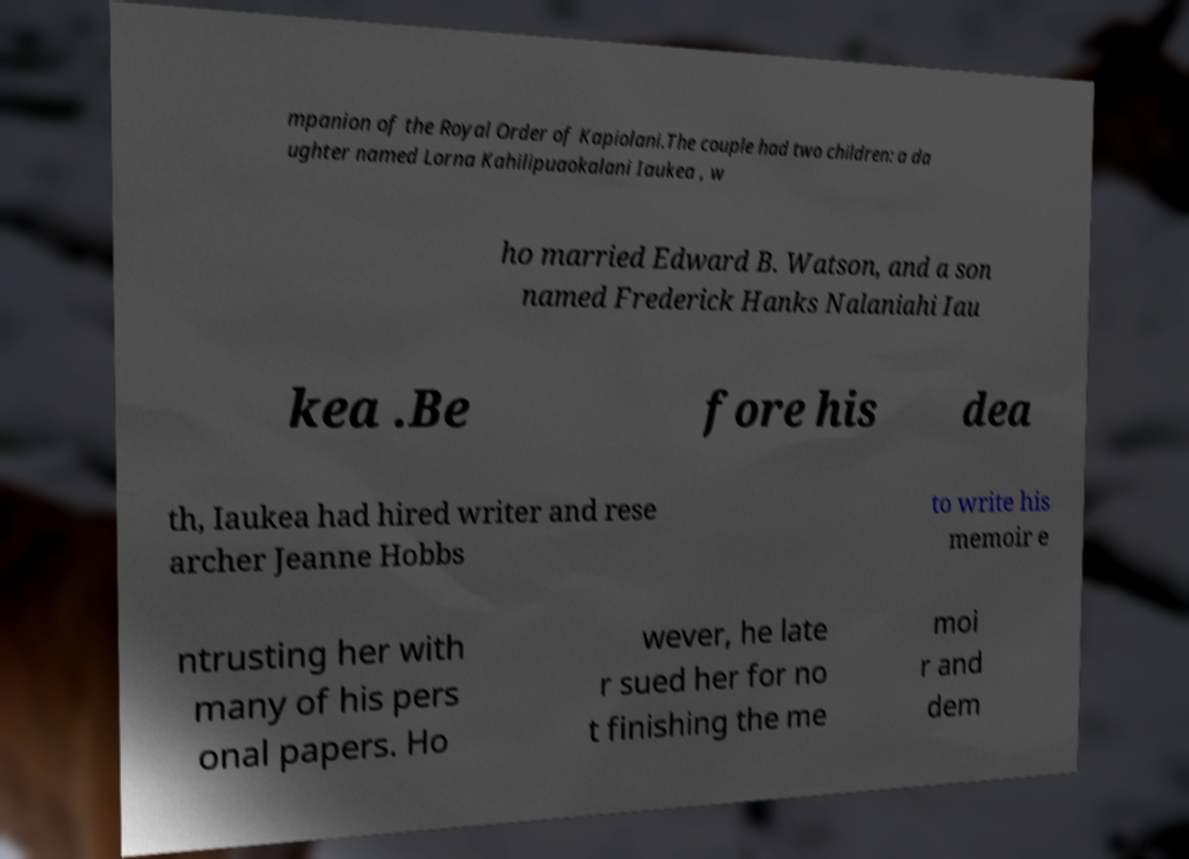Can you read and provide the text displayed in the image?This photo seems to have some interesting text. Can you extract and type it out for me? mpanion of the Royal Order of Kapiolani.The couple had two children: a da ughter named Lorna Kahilipuaokalani Iaukea , w ho married Edward B. Watson, and a son named Frederick Hanks Nalaniahi Iau kea .Be fore his dea th, Iaukea had hired writer and rese archer Jeanne Hobbs to write his memoir e ntrusting her with many of his pers onal papers. Ho wever, he late r sued her for no t finishing the me moi r and dem 